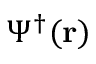Convert formula to latex. <formula><loc_0><loc_0><loc_500><loc_500>\Psi ^ { \dagger } ( r )</formula> 